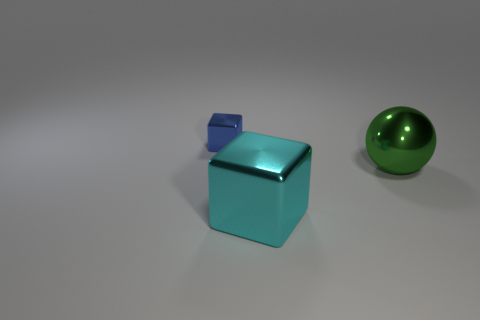Add 1 small yellow matte cubes. How many objects exist? 4 Subtract all cyan cubes. How many cubes are left? 1 Subtract 1 spheres. How many spheres are left? 0 Subtract all red cubes. Subtract all metallic objects. How many objects are left? 0 Add 2 large green objects. How many large green objects are left? 3 Add 2 large cyan cylinders. How many large cyan cylinders exist? 2 Subtract 0 gray blocks. How many objects are left? 3 Subtract all cubes. How many objects are left? 1 Subtract all yellow balls. Subtract all green cylinders. How many balls are left? 1 